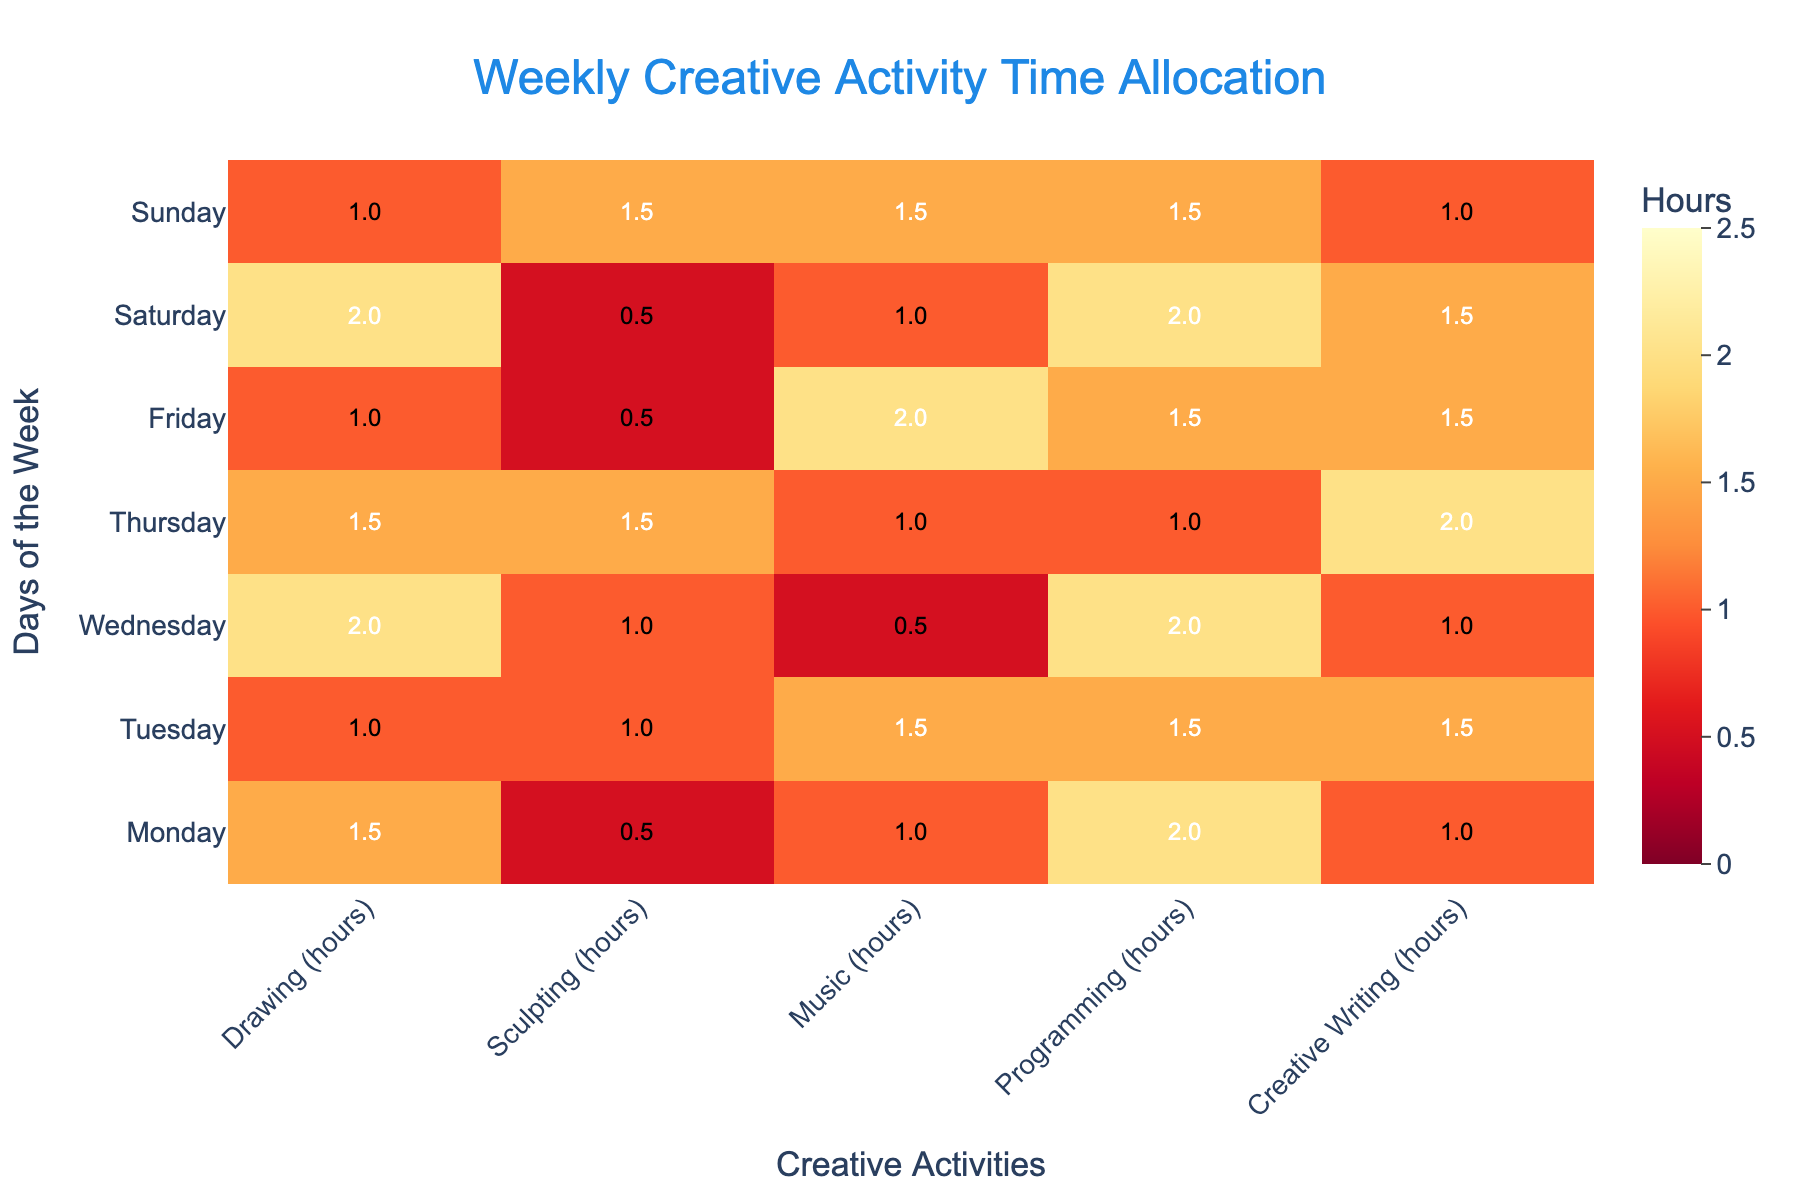What is the title of the heatmap? The title is typically displayed at the top of the heatmap and provides an overview of what the heatmap represents.
Answer: Weekly Creative Activity Time Allocation Which day has the highest total time allocated to creative activities? Sum up the hours for each creative activity on each day, and compare the totals to find the highest one. For instance, Monday has (1.5+0.5+1.0+2.0+1.0) = 6 hours, Tuesday has (1.0+1.0+1.5+1.5+1.5) = 6.5 hours, and so forth. The day with the highest total is Tuesday with 6.5 hours.
Answer: Tuesday On which day is the time spent on Creative Writing the highest? Referring to the numbers in the heatmap for Creative Writing across the days: Monday (1.0), Tuesday (1.5), Wednesday (1.0), Thursday (2.0), Friday (1.5), Saturday (1.5), Sunday (1.0). The highest value is 2.0 on Thursday.
Answer: Thursday How many hours are spent on Drawing on Wednesday? Look at the heatmap for the intersection of Drawing and Wednesday. The value there is 2.0 hours.
Answer: 2.0 hours What's the total time spent on Programming throughout the week? Add up the hours for Programming on each day: Monday (2.0), Tuesday (1.5), Wednesday (2.0), Thursday (1.0), Friday (1.5), Saturday (2.0), Sunday (1.5). The total is (2.0 + 1.5 + 2.0 + 1.0 + 1.5 + 2.0 + 1.5) = 11.5 hours.
Answer: 11.5 hours Which activity has the lowest average time allocation across the week? Calculate the average for each activity: 
Drawing: (1.5+1.0+2.0+1.5+1.0+2.0+1.0)/7 = 1.43 hours
Sculpting: (0.5+1.0+1.0+1.5+0.5+0.5+1.5)/7 = 0.93 hours
Music: (1.0+1.5+0.5+1.0+2.0+1.0+1.5)/7 = 1.21 hours
Programming: (2.0+1.5+2.0+1.0+1.5+2.0+1.5)/7 = 1.64 hours
Creative Writing: (1.0+1.5+1.0+2.0+1.5+1.5+1.0)/7 = 1.36 hours
Sculpting has the lowest average time.
Answer: Sculpting Which day has an equal amount of hours allocated to Drawing and Music? Check for equality in the numbers under Drawing and Music for each day. On Saturday, both Drawing and Music have 2.0 hours each.
Answer: Saturday How many days have Sculpting hours more than 1.0? Compare Sculpting hours for each day with 1.0: 
Monday (0.5), Tuesday (1.0), Wednesday (1.0), Thursday (1.5), Friday (0.5), Saturday (0.5), Sunday (1.5). Only Thursday and Sunday have more than 1.0 hours.
Answer: 2 days On which day is the time distribution across activities most varied? Look at the range of hours for each day to identify the most varied: 
Monday (1.5, 0.5, 1.0, 2.0, 1.0), range = 1.5
Tuesday (1.0, 1.0, 1.5, 1.5, 1.5), range = 0.5
Wednesday (2.0, 1.0, 0.5, 2.0, 1.0), range = 1.5
Thursday (1.5, 1.5, 1.0, 1.0, 2.0), range = 1.0
Friday (1.0, 0.5, 2.0, 1.5, 1.5), range = 1.5
Saturday (2.0, 0.5, 1.0, 2.0, 1.5), range = 1.5
Sunday (1.0, 1.5, 1.5, 1.5, 1.0), range = 0.5
The days with the highest range (1.5) are Monday, Wednesday, Friday, and Saturday, indicating the most varied distribution across activities.
Answer: Monday, Wednesday, Friday, Saturday 